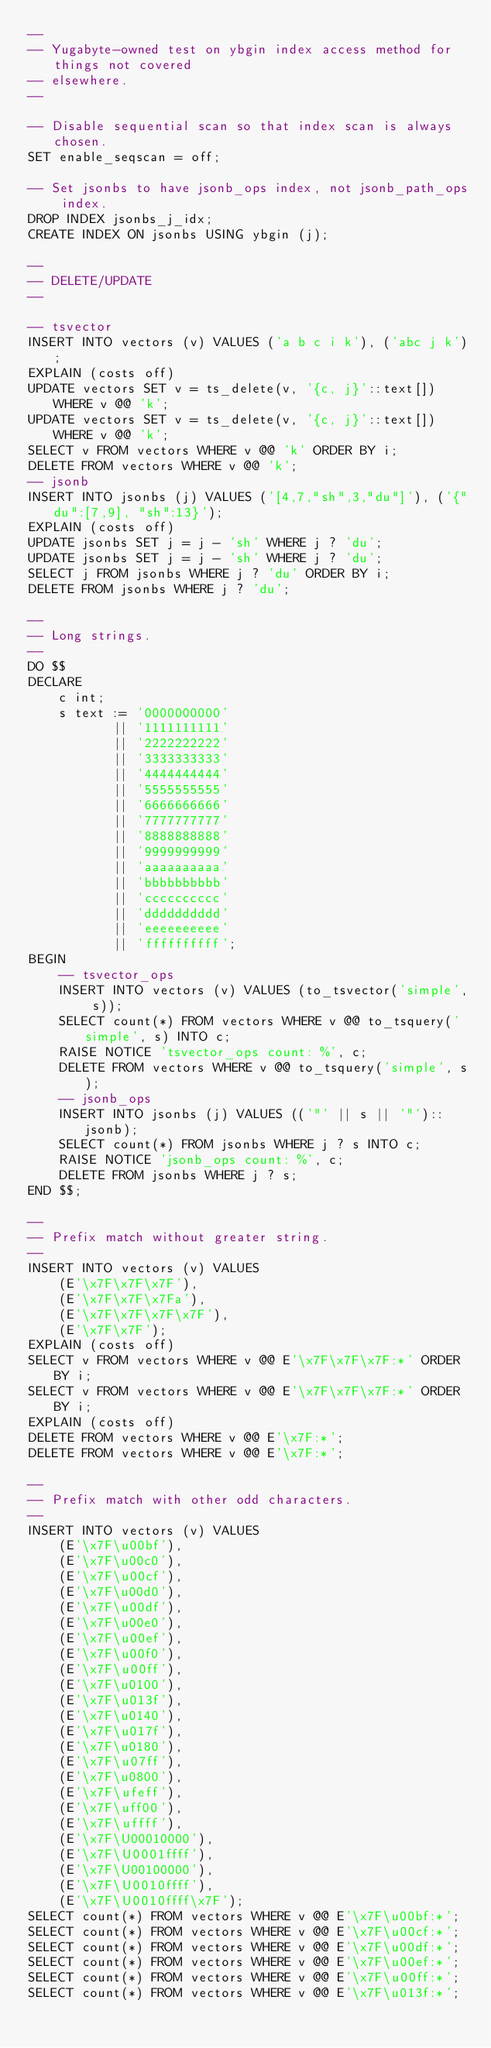Convert code to text. <code><loc_0><loc_0><loc_500><loc_500><_SQL_>--
-- Yugabyte-owned test on ybgin index access method for things not covered
-- elsewhere.
--

-- Disable sequential scan so that index scan is always chosen.
SET enable_seqscan = off;

-- Set jsonbs to have jsonb_ops index, not jsonb_path_ops index.
DROP INDEX jsonbs_j_idx;
CREATE INDEX ON jsonbs USING ybgin (j);

--
-- DELETE/UPDATE
--

-- tsvector
INSERT INTO vectors (v) VALUES ('a b c i k'), ('abc j k');
EXPLAIN (costs off)
UPDATE vectors SET v = ts_delete(v, '{c, j}'::text[]) WHERE v @@ 'k';
UPDATE vectors SET v = ts_delete(v, '{c, j}'::text[]) WHERE v @@ 'k';
SELECT v FROM vectors WHERE v @@ 'k' ORDER BY i;
DELETE FROM vectors WHERE v @@ 'k';
-- jsonb
INSERT INTO jsonbs (j) VALUES ('[4,7,"sh",3,"du"]'), ('{"du":[7,9], "sh":13}');
EXPLAIN (costs off)
UPDATE jsonbs SET j = j - 'sh' WHERE j ? 'du';
UPDATE jsonbs SET j = j - 'sh' WHERE j ? 'du';
SELECT j FROM jsonbs WHERE j ? 'du' ORDER BY i;
DELETE FROM jsonbs WHERE j ? 'du';

--
-- Long strings.
--
DO $$
DECLARE
    c int;
    s text := '0000000000'
           || '1111111111'
           || '2222222222'
           || '3333333333'
           || '4444444444'
           || '5555555555'
           || '6666666666'
           || '7777777777'
           || '8888888888'
           || '9999999999'
           || 'aaaaaaaaaa'
           || 'bbbbbbbbbb'
           || 'cccccccccc'
           || 'dddddddddd'
           || 'eeeeeeeeee'
           || 'ffffffffff';
BEGIN
    -- tsvector_ops
    INSERT INTO vectors (v) VALUES (to_tsvector('simple', s));
    SELECT count(*) FROM vectors WHERE v @@ to_tsquery('simple', s) INTO c;
    RAISE NOTICE 'tsvector_ops count: %', c;
    DELETE FROM vectors WHERE v @@ to_tsquery('simple', s);
    -- jsonb_ops
    INSERT INTO jsonbs (j) VALUES (('"' || s || '"')::jsonb);
    SELECT count(*) FROM jsonbs WHERE j ? s INTO c;
    RAISE NOTICE 'jsonb_ops count: %', c;
    DELETE FROM jsonbs WHERE j ? s;
END $$;

--
-- Prefix match without greater string.
--
INSERT INTO vectors (v) VALUES
    (E'\x7F\x7F\x7F'),
    (E'\x7F\x7F\x7Fa'),
    (E'\x7F\x7F\x7F\x7F'),
    (E'\x7F\x7F');
EXPLAIN (costs off)
SELECT v FROM vectors WHERE v @@ E'\x7F\x7F\x7F:*' ORDER BY i;
SELECT v FROM vectors WHERE v @@ E'\x7F\x7F\x7F:*' ORDER BY i;
EXPLAIN (costs off)
DELETE FROM vectors WHERE v @@ E'\x7F:*';
DELETE FROM vectors WHERE v @@ E'\x7F:*';

--
-- Prefix match with other odd characters.
--
INSERT INTO vectors (v) VALUES
    (E'\x7F\u00bf'),
    (E'\x7F\u00c0'),
    (E'\x7F\u00cf'),
    (E'\x7F\u00d0'),
    (E'\x7F\u00df'),
    (E'\x7F\u00e0'),
    (E'\x7F\u00ef'),
    (E'\x7F\u00f0'),
    (E'\x7F\u00ff'),
    (E'\x7F\u0100'),
    (E'\x7F\u013f'),
    (E'\x7F\u0140'),
    (E'\x7F\u017f'),
    (E'\x7F\u0180'),
    (E'\x7F\u07ff'),
    (E'\x7F\u0800'),
    (E'\x7F\ufeff'),
    (E'\x7F\uff00'),
    (E'\x7F\uffff'),
    (E'\x7F\U00010000'),
    (E'\x7F\U0001ffff'),
    (E'\x7F\U00100000'),
    (E'\x7F\U0010ffff'),
    (E'\x7F\U0010ffff\x7F');
SELECT count(*) FROM vectors WHERE v @@ E'\x7F\u00bf:*';
SELECT count(*) FROM vectors WHERE v @@ E'\x7F\u00cf:*';
SELECT count(*) FROM vectors WHERE v @@ E'\x7F\u00df:*';
SELECT count(*) FROM vectors WHERE v @@ E'\x7F\u00ef:*';
SELECT count(*) FROM vectors WHERE v @@ E'\x7F\u00ff:*';
SELECT count(*) FROM vectors WHERE v @@ E'\x7F\u013f:*';</code> 